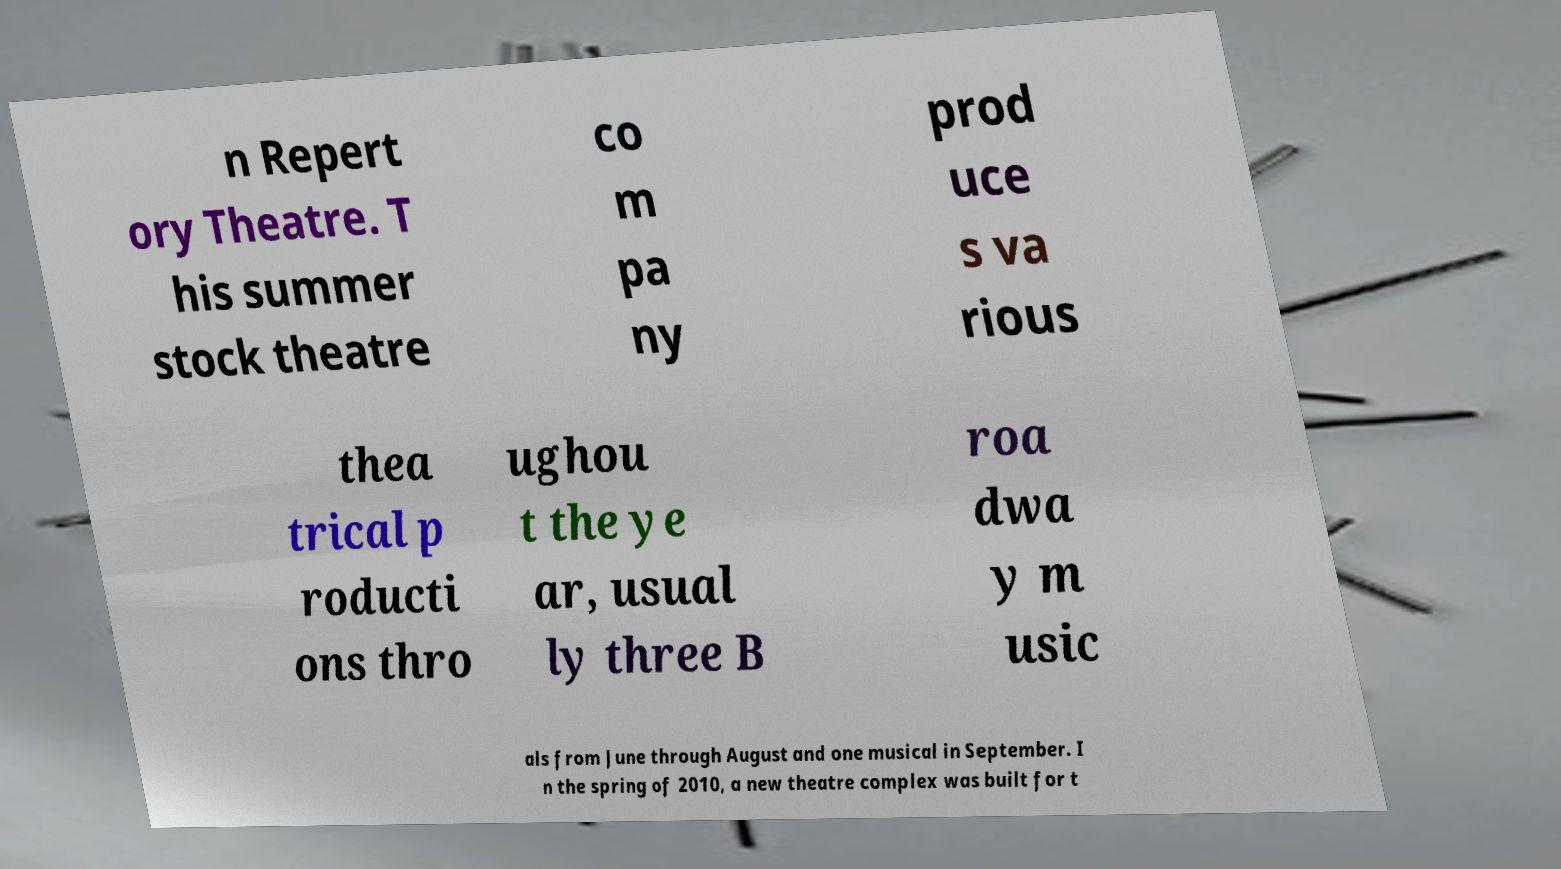What messages or text are displayed in this image? I need them in a readable, typed format. n Repert ory Theatre. T his summer stock theatre co m pa ny prod uce s va rious thea trical p roducti ons thro ughou t the ye ar, usual ly three B roa dwa y m usic als from June through August and one musical in September. I n the spring of 2010, a new theatre complex was built for t 